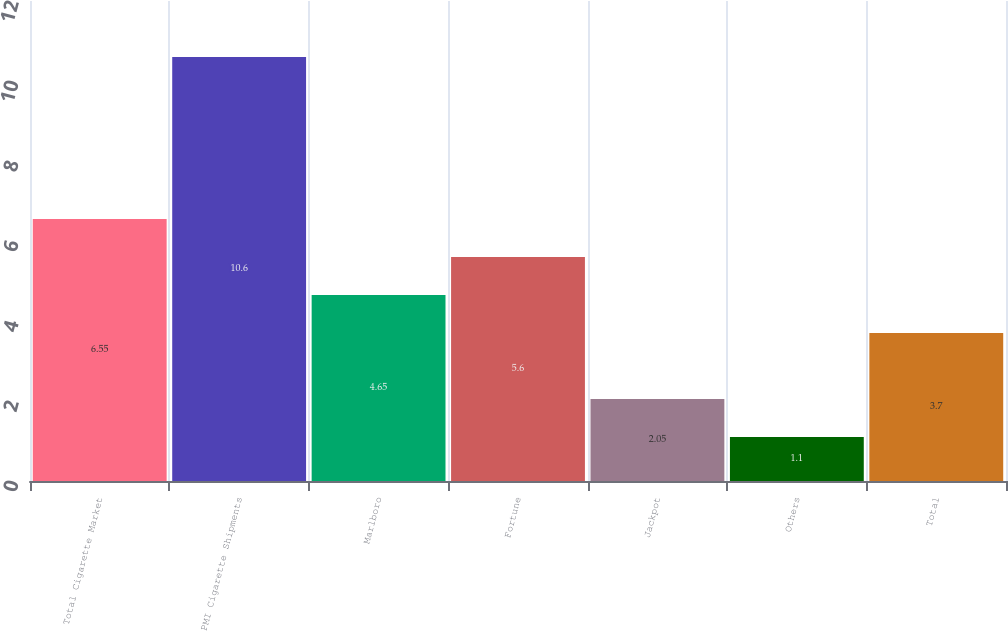Convert chart to OTSL. <chart><loc_0><loc_0><loc_500><loc_500><bar_chart><fcel>Total Cigarette Market<fcel>PMI Cigarette Shipments<fcel>Marlboro<fcel>Fortune<fcel>Jackpot<fcel>Others<fcel>Total<nl><fcel>6.55<fcel>10.6<fcel>4.65<fcel>5.6<fcel>2.05<fcel>1.1<fcel>3.7<nl></chart> 